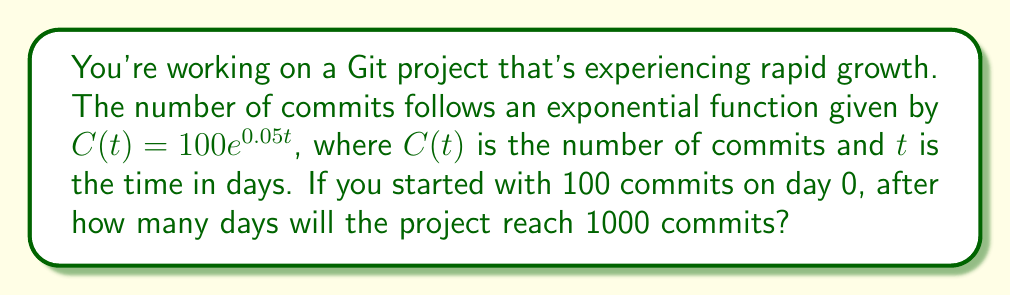Can you solve this math problem? Let's approach this step-by-step:

1) We're given the exponential function: $C(t) = 100e^{0.05t}$

2) We want to find $t$ when $C(t) = 1000$. So, let's set up the equation:

   $1000 = 100e^{0.05t}$

3) Divide both sides by 100:

   $10 = e^{0.05t}$

4) Take the natural log of both sides:

   $\ln(10) = \ln(e^{0.05t})$

5) Simplify the right side using the property of logarithms:

   $\ln(10) = 0.05t$

6) Divide both sides by 0.05:

   $\frac{\ln(10)}{0.05} = t$

7) Calculate the result:

   $t \approx 46.05$

8) Since we're dealing with days, we need to round up to the next whole number:

   $t = 47$

Therefore, it will take 47 days for the project to reach 1000 commits.
Answer: 47 days 